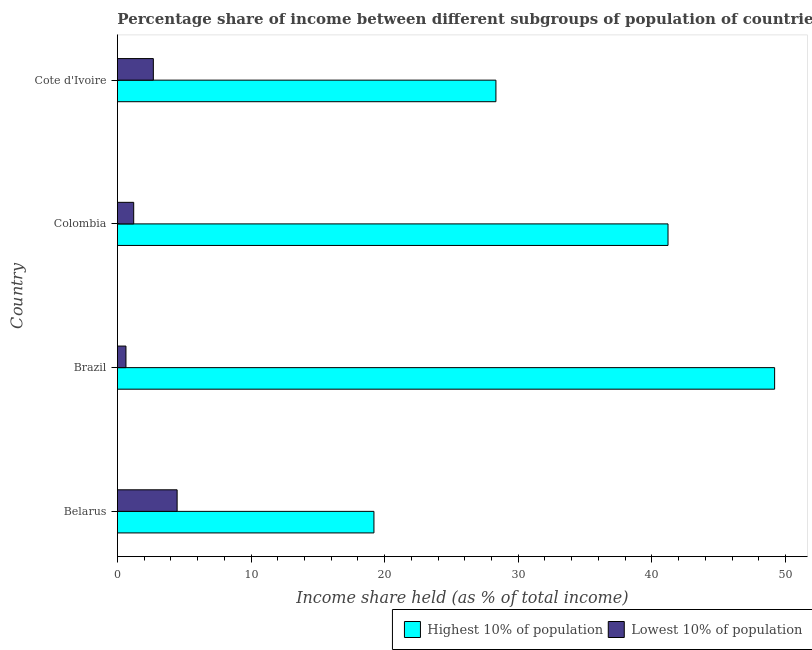Are the number of bars on each tick of the Y-axis equal?
Keep it short and to the point. Yes. How many bars are there on the 4th tick from the top?
Keep it short and to the point. 2. How many bars are there on the 3rd tick from the bottom?
Offer a very short reply. 2. What is the label of the 1st group of bars from the top?
Provide a short and direct response. Cote d'Ivoire. What is the income share held by highest 10% of the population in Belarus?
Ensure brevity in your answer.  19.2. Across all countries, what is the maximum income share held by highest 10% of the population?
Make the answer very short. 49.19. Across all countries, what is the minimum income share held by lowest 10% of the population?
Give a very brief answer. 0.64. In which country was the income share held by highest 10% of the population maximum?
Offer a very short reply. Brazil. In which country was the income share held by lowest 10% of the population minimum?
Offer a very short reply. Brazil. What is the total income share held by highest 10% of the population in the graph?
Make the answer very short. 137.93. What is the difference between the income share held by lowest 10% of the population in Brazil and that in Colombia?
Your response must be concise. -0.58. What is the difference between the income share held by lowest 10% of the population in Colombia and the income share held by highest 10% of the population in Brazil?
Provide a short and direct response. -47.97. What is the average income share held by highest 10% of the population per country?
Your answer should be compact. 34.48. What is the difference between the income share held by lowest 10% of the population and income share held by highest 10% of the population in Colombia?
Your response must be concise. -39.99. What is the ratio of the income share held by lowest 10% of the population in Belarus to that in Cote d'Ivoire?
Offer a very short reply. 1.66. Is the difference between the income share held by lowest 10% of the population in Belarus and Colombia greater than the difference between the income share held by highest 10% of the population in Belarus and Colombia?
Offer a terse response. Yes. What is the difference between the highest and the second highest income share held by highest 10% of the population?
Your answer should be very brief. 7.98. What is the difference between the highest and the lowest income share held by lowest 10% of the population?
Provide a succinct answer. 3.83. In how many countries, is the income share held by highest 10% of the population greater than the average income share held by highest 10% of the population taken over all countries?
Offer a very short reply. 2. What does the 1st bar from the top in Brazil represents?
Your answer should be very brief. Lowest 10% of population. What does the 2nd bar from the bottom in Brazil represents?
Your answer should be very brief. Lowest 10% of population. Are all the bars in the graph horizontal?
Your answer should be compact. Yes. How many countries are there in the graph?
Offer a terse response. 4. What is the difference between two consecutive major ticks on the X-axis?
Offer a terse response. 10. How many legend labels are there?
Your response must be concise. 2. How are the legend labels stacked?
Offer a very short reply. Horizontal. What is the title of the graph?
Offer a terse response. Percentage share of income between different subgroups of population of countries. Does "By country of origin" appear as one of the legend labels in the graph?
Make the answer very short. No. What is the label or title of the X-axis?
Offer a terse response. Income share held (as % of total income). What is the label or title of the Y-axis?
Your response must be concise. Country. What is the Income share held (as % of total income) of Highest 10% of population in Belarus?
Make the answer very short. 19.2. What is the Income share held (as % of total income) in Lowest 10% of population in Belarus?
Keep it short and to the point. 4.47. What is the Income share held (as % of total income) in Highest 10% of population in Brazil?
Keep it short and to the point. 49.19. What is the Income share held (as % of total income) in Lowest 10% of population in Brazil?
Your response must be concise. 0.64. What is the Income share held (as % of total income) in Highest 10% of population in Colombia?
Give a very brief answer. 41.21. What is the Income share held (as % of total income) in Lowest 10% of population in Colombia?
Give a very brief answer. 1.22. What is the Income share held (as % of total income) of Highest 10% of population in Cote d'Ivoire?
Provide a short and direct response. 28.33. What is the Income share held (as % of total income) in Lowest 10% of population in Cote d'Ivoire?
Your response must be concise. 2.69. Across all countries, what is the maximum Income share held (as % of total income) of Highest 10% of population?
Offer a very short reply. 49.19. Across all countries, what is the maximum Income share held (as % of total income) in Lowest 10% of population?
Your answer should be compact. 4.47. Across all countries, what is the minimum Income share held (as % of total income) in Highest 10% of population?
Provide a succinct answer. 19.2. Across all countries, what is the minimum Income share held (as % of total income) in Lowest 10% of population?
Provide a succinct answer. 0.64. What is the total Income share held (as % of total income) of Highest 10% of population in the graph?
Provide a succinct answer. 137.93. What is the total Income share held (as % of total income) in Lowest 10% of population in the graph?
Provide a short and direct response. 9.02. What is the difference between the Income share held (as % of total income) in Highest 10% of population in Belarus and that in Brazil?
Keep it short and to the point. -29.99. What is the difference between the Income share held (as % of total income) in Lowest 10% of population in Belarus and that in Brazil?
Ensure brevity in your answer.  3.83. What is the difference between the Income share held (as % of total income) of Highest 10% of population in Belarus and that in Colombia?
Provide a succinct answer. -22.01. What is the difference between the Income share held (as % of total income) in Lowest 10% of population in Belarus and that in Colombia?
Provide a succinct answer. 3.25. What is the difference between the Income share held (as % of total income) of Highest 10% of population in Belarus and that in Cote d'Ivoire?
Keep it short and to the point. -9.13. What is the difference between the Income share held (as % of total income) in Lowest 10% of population in Belarus and that in Cote d'Ivoire?
Your answer should be compact. 1.78. What is the difference between the Income share held (as % of total income) in Highest 10% of population in Brazil and that in Colombia?
Keep it short and to the point. 7.98. What is the difference between the Income share held (as % of total income) in Lowest 10% of population in Brazil and that in Colombia?
Your answer should be very brief. -0.58. What is the difference between the Income share held (as % of total income) in Highest 10% of population in Brazil and that in Cote d'Ivoire?
Provide a succinct answer. 20.86. What is the difference between the Income share held (as % of total income) of Lowest 10% of population in Brazil and that in Cote d'Ivoire?
Your answer should be very brief. -2.05. What is the difference between the Income share held (as % of total income) in Highest 10% of population in Colombia and that in Cote d'Ivoire?
Your answer should be very brief. 12.88. What is the difference between the Income share held (as % of total income) in Lowest 10% of population in Colombia and that in Cote d'Ivoire?
Keep it short and to the point. -1.47. What is the difference between the Income share held (as % of total income) in Highest 10% of population in Belarus and the Income share held (as % of total income) in Lowest 10% of population in Brazil?
Offer a very short reply. 18.56. What is the difference between the Income share held (as % of total income) in Highest 10% of population in Belarus and the Income share held (as % of total income) in Lowest 10% of population in Colombia?
Your answer should be compact. 17.98. What is the difference between the Income share held (as % of total income) of Highest 10% of population in Belarus and the Income share held (as % of total income) of Lowest 10% of population in Cote d'Ivoire?
Your response must be concise. 16.51. What is the difference between the Income share held (as % of total income) in Highest 10% of population in Brazil and the Income share held (as % of total income) in Lowest 10% of population in Colombia?
Your response must be concise. 47.97. What is the difference between the Income share held (as % of total income) of Highest 10% of population in Brazil and the Income share held (as % of total income) of Lowest 10% of population in Cote d'Ivoire?
Provide a short and direct response. 46.5. What is the difference between the Income share held (as % of total income) of Highest 10% of population in Colombia and the Income share held (as % of total income) of Lowest 10% of population in Cote d'Ivoire?
Offer a terse response. 38.52. What is the average Income share held (as % of total income) in Highest 10% of population per country?
Offer a terse response. 34.48. What is the average Income share held (as % of total income) in Lowest 10% of population per country?
Make the answer very short. 2.25. What is the difference between the Income share held (as % of total income) of Highest 10% of population and Income share held (as % of total income) of Lowest 10% of population in Belarus?
Your answer should be very brief. 14.73. What is the difference between the Income share held (as % of total income) of Highest 10% of population and Income share held (as % of total income) of Lowest 10% of population in Brazil?
Provide a short and direct response. 48.55. What is the difference between the Income share held (as % of total income) of Highest 10% of population and Income share held (as % of total income) of Lowest 10% of population in Colombia?
Your answer should be very brief. 39.99. What is the difference between the Income share held (as % of total income) in Highest 10% of population and Income share held (as % of total income) in Lowest 10% of population in Cote d'Ivoire?
Your answer should be compact. 25.64. What is the ratio of the Income share held (as % of total income) of Highest 10% of population in Belarus to that in Brazil?
Make the answer very short. 0.39. What is the ratio of the Income share held (as % of total income) in Lowest 10% of population in Belarus to that in Brazil?
Your answer should be compact. 6.98. What is the ratio of the Income share held (as % of total income) in Highest 10% of population in Belarus to that in Colombia?
Give a very brief answer. 0.47. What is the ratio of the Income share held (as % of total income) in Lowest 10% of population in Belarus to that in Colombia?
Offer a very short reply. 3.66. What is the ratio of the Income share held (as % of total income) of Highest 10% of population in Belarus to that in Cote d'Ivoire?
Provide a short and direct response. 0.68. What is the ratio of the Income share held (as % of total income) in Lowest 10% of population in Belarus to that in Cote d'Ivoire?
Offer a terse response. 1.66. What is the ratio of the Income share held (as % of total income) of Highest 10% of population in Brazil to that in Colombia?
Provide a succinct answer. 1.19. What is the ratio of the Income share held (as % of total income) of Lowest 10% of population in Brazil to that in Colombia?
Keep it short and to the point. 0.52. What is the ratio of the Income share held (as % of total income) of Highest 10% of population in Brazil to that in Cote d'Ivoire?
Your answer should be very brief. 1.74. What is the ratio of the Income share held (as % of total income) in Lowest 10% of population in Brazil to that in Cote d'Ivoire?
Ensure brevity in your answer.  0.24. What is the ratio of the Income share held (as % of total income) in Highest 10% of population in Colombia to that in Cote d'Ivoire?
Your answer should be very brief. 1.45. What is the ratio of the Income share held (as % of total income) in Lowest 10% of population in Colombia to that in Cote d'Ivoire?
Offer a terse response. 0.45. What is the difference between the highest and the second highest Income share held (as % of total income) in Highest 10% of population?
Your answer should be very brief. 7.98. What is the difference between the highest and the second highest Income share held (as % of total income) in Lowest 10% of population?
Your answer should be very brief. 1.78. What is the difference between the highest and the lowest Income share held (as % of total income) of Highest 10% of population?
Provide a short and direct response. 29.99. What is the difference between the highest and the lowest Income share held (as % of total income) in Lowest 10% of population?
Your answer should be compact. 3.83. 